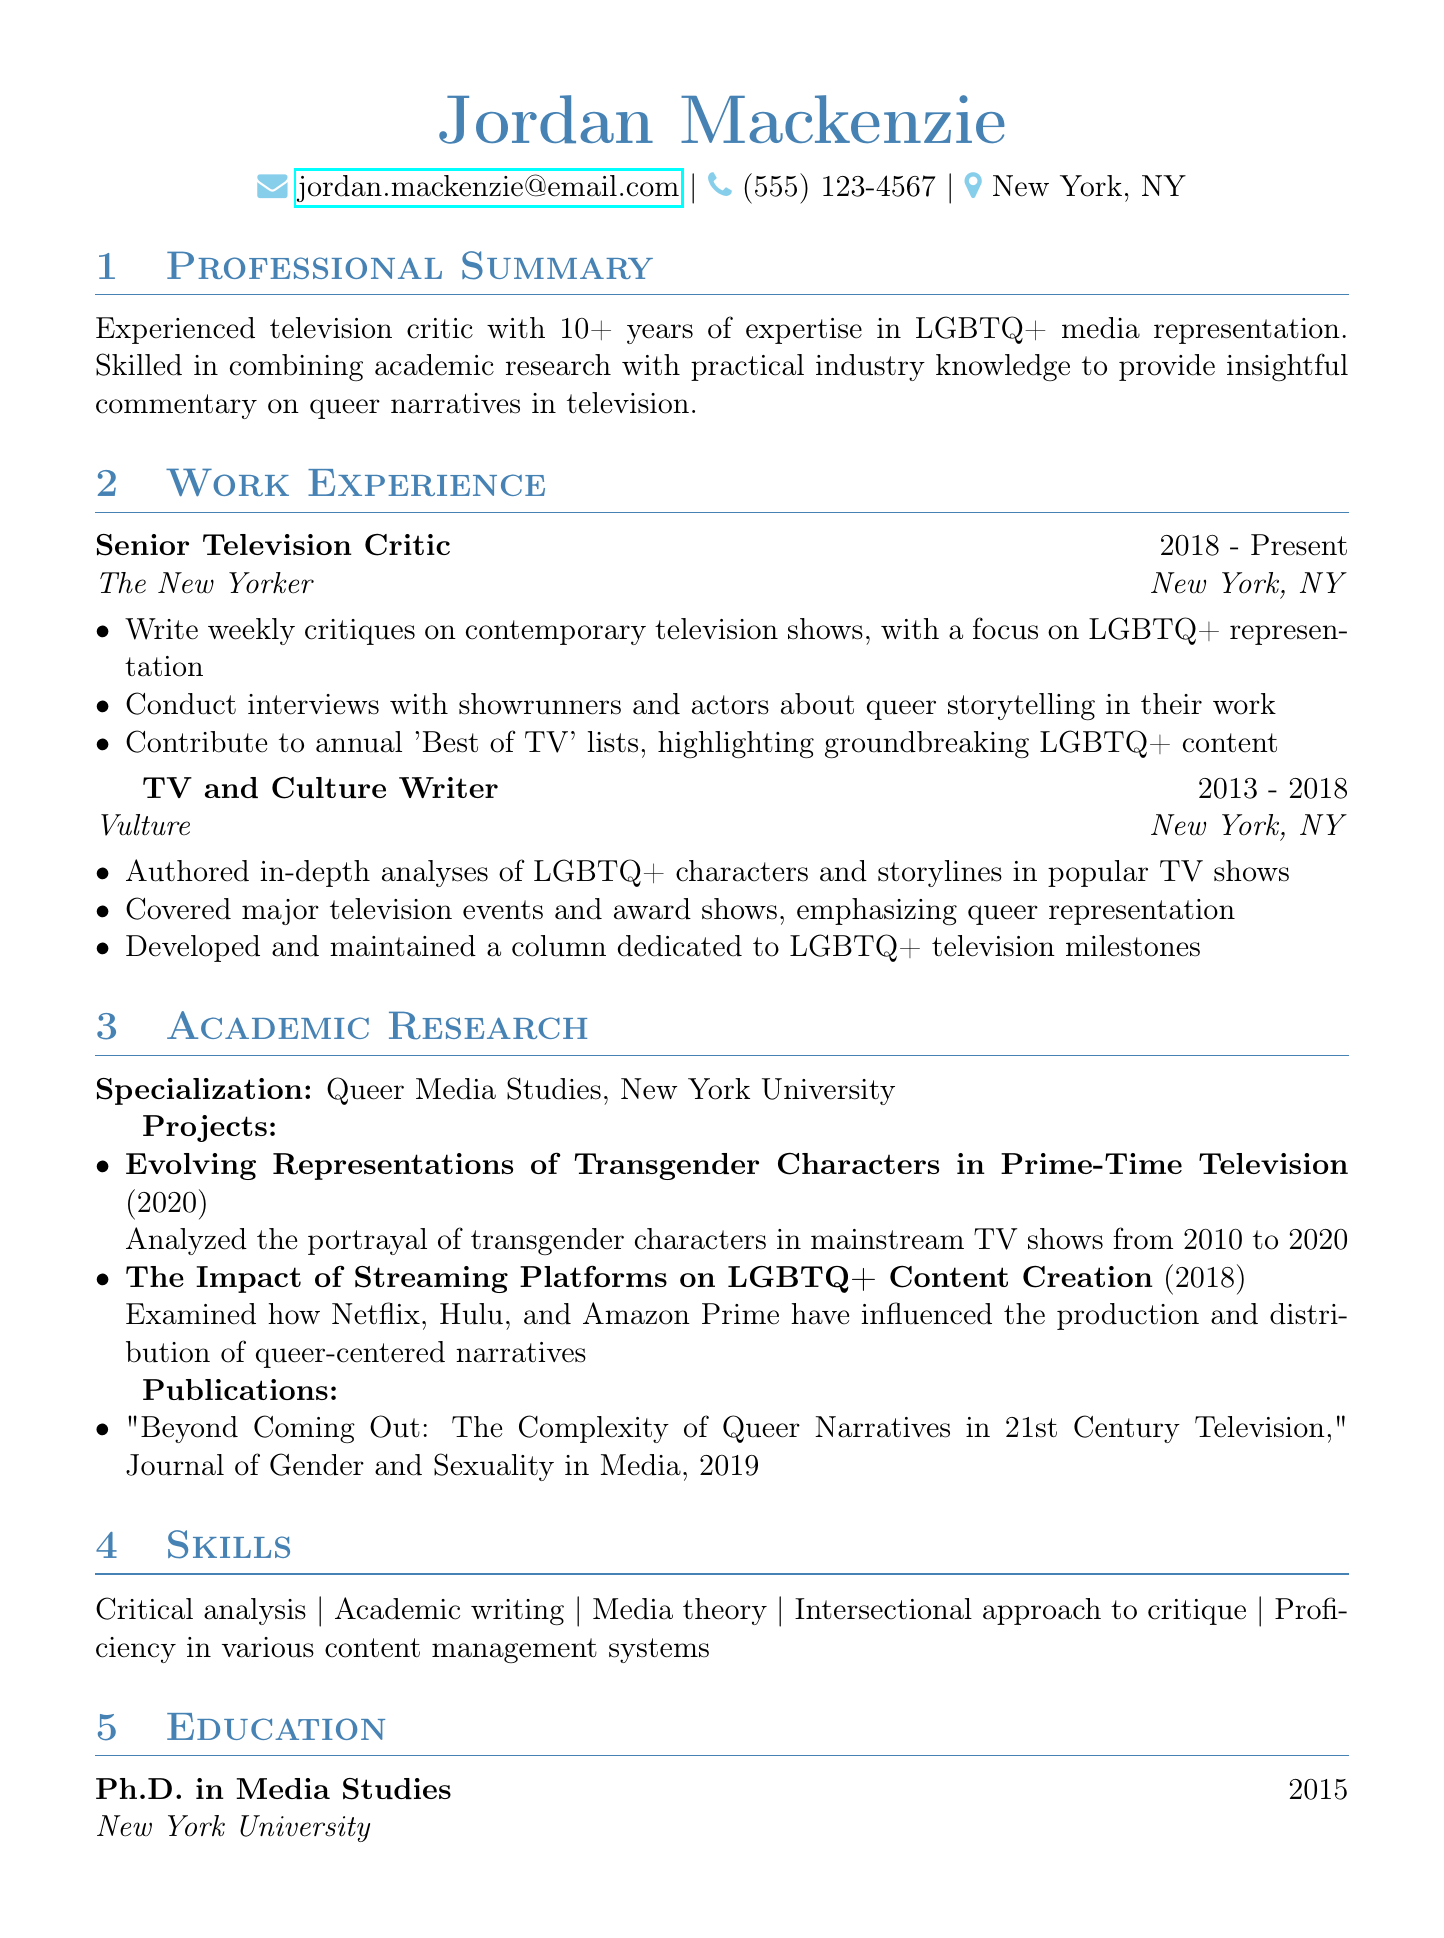What is the name of the individual in the resume? The individual's name is prominently displayed at the top of the document.
Answer: Jordan Mackenzie What is Jordan Mackenzie's Ph.D. specialization? The resume explicitly states the academic specialization under the academic research section.
Answer: Media Studies How many years of experience does Jordan Mackenzie have? The professional summary provides a specific number of years of experience.
Answer: 10+ Which publication features Jordan Mackenzie's article? The publications section lists the journal where the article is published.
Answer: Journal of Gender and Sexuality in Media What is the title of the current position held by Jordan Mackenzie? The work experience section lists the current job title under the most recent entry.
Answer: Senior Television Critic What was the focus of the research project completed in 2020? The projects listed in the academic research section detail the research focus for that year.
Answer: Representations of Transgender Characters In which city is Jordan Mackenzie located? The location information is clearly stated in the contact details of the document.
Answer: New York, NY What skills are highlighted in the skills section? The skills section summarizes the main abilities and proficiencies listed.
Answer: Critical analysis, Academic writing, Media theory, Intersectional approach to critique, Proficiency in various content management systems What was the role of Jordan Mackenzie at Vulture? The work experience section provides the job title held at Vulture.
Answer: TV and Culture Writer 